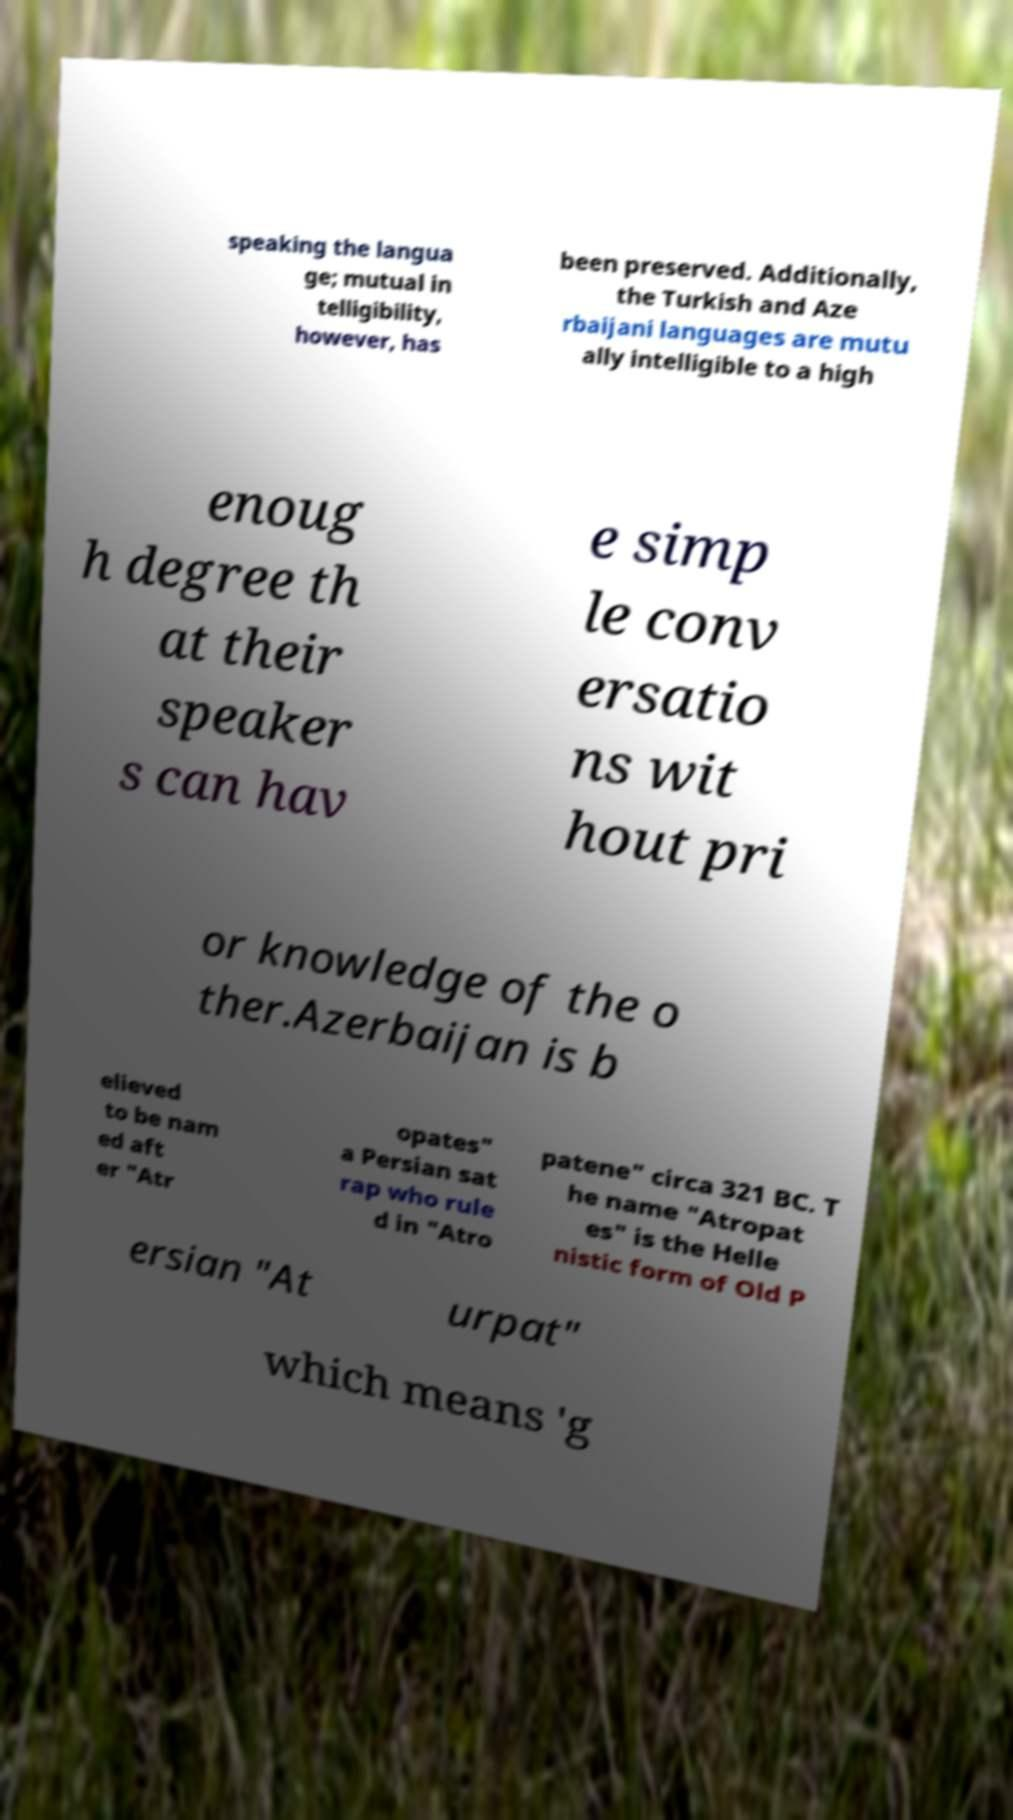What messages or text are displayed in this image? I need them in a readable, typed format. speaking the langua ge; mutual in telligibility, however, has been preserved. Additionally, the Turkish and Aze rbaijani languages are mutu ally intelligible to a high enoug h degree th at their speaker s can hav e simp le conv ersatio ns wit hout pri or knowledge of the o ther.Azerbaijan is b elieved to be nam ed aft er "Atr opates" a Persian sat rap who rule d in "Atro patene" circa 321 BC. T he name "Atropat es" is the Helle nistic form of Old P ersian "At urpat" which means 'g 